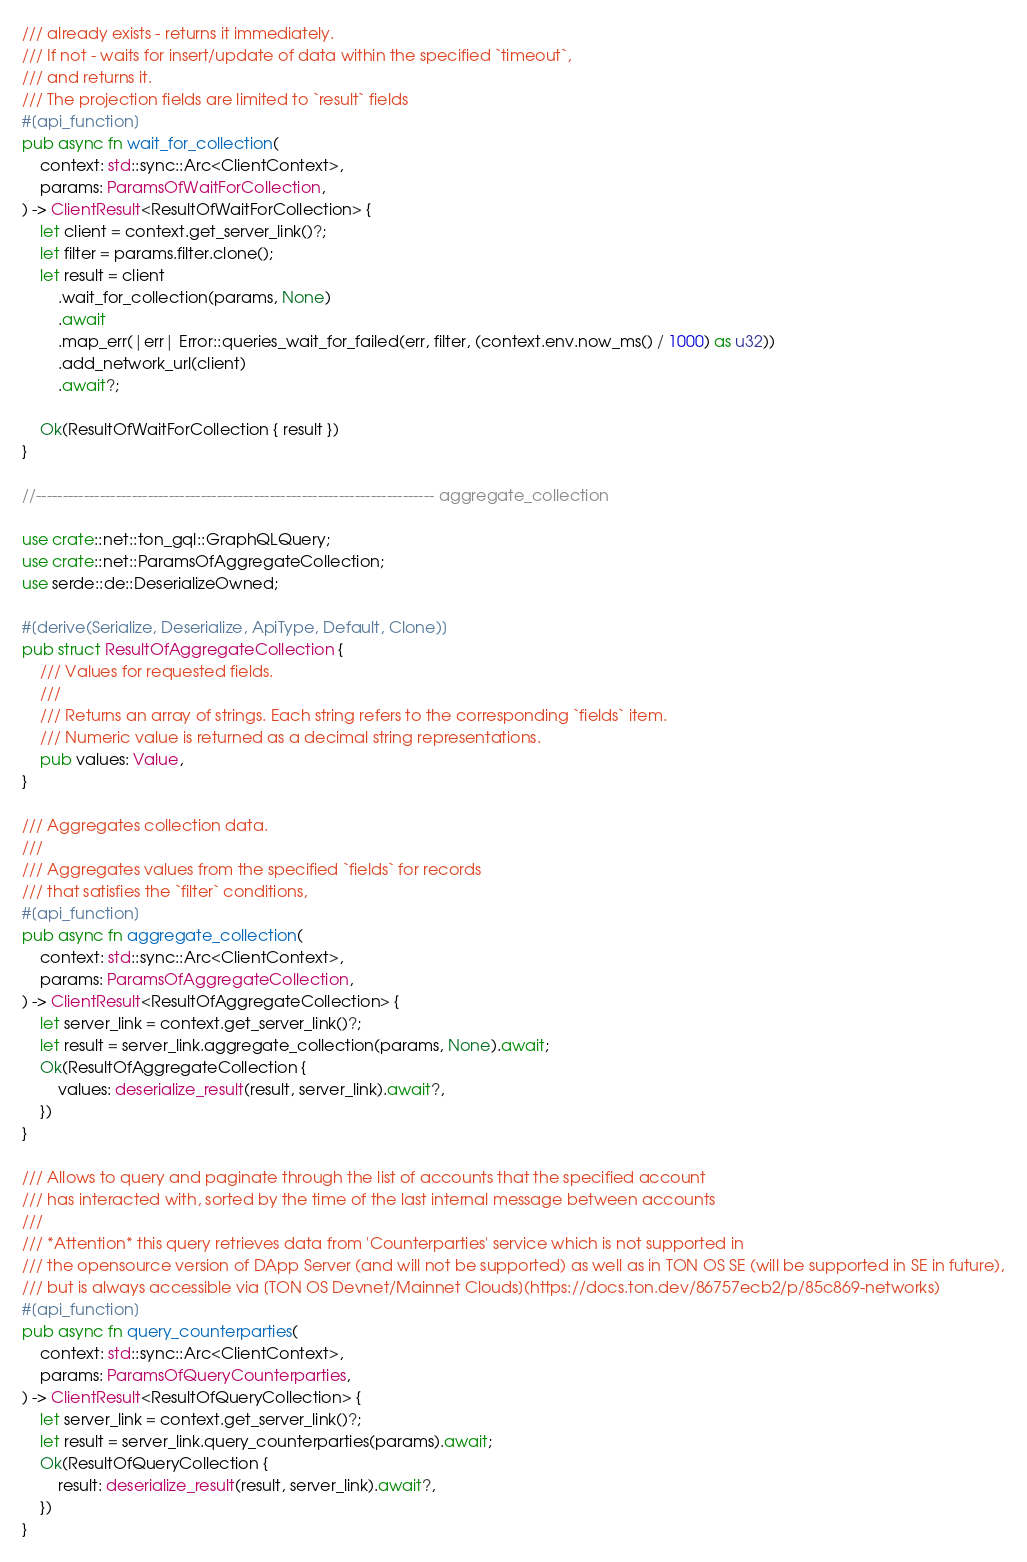Convert code to text. <code><loc_0><loc_0><loc_500><loc_500><_Rust_>/// already exists - returns it immediately.
/// If not - waits for insert/update of data within the specified `timeout`,
/// and returns it.
/// The projection fields are limited to `result` fields
#[api_function]
pub async fn wait_for_collection(
    context: std::sync::Arc<ClientContext>,
    params: ParamsOfWaitForCollection,
) -> ClientResult<ResultOfWaitForCollection> {
    let client = context.get_server_link()?;
    let filter = params.filter.clone();
    let result = client
        .wait_for_collection(params, None)
        .await
        .map_err(|err| Error::queries_wait_for_failed(err, filter, (context.env.now_ms() / 1000) as u32))
        .add_network_url(client)
        .await?;

    Ok(ResultOfWaitForCollection { result })
}

//--------------------------------------------------------------------------- aggregate_collection

use crate::net::ton_gql::GraphQLQuery;
use crate::net::ParamsOfAggregateCollection;
use serde::de::DeserializeOwned;

#[derive(Serialize, Deserialize, ApiType, Default, Clone)]
pub struct ResultOfAggregateCollection {
    /// Values for requested fields.
    ///
    /// Returns an array of strings. Each string refers to the corresponding `fields` item.
    /// Numeric value is returned as a decimal string representations.
    pub values: Value,
}

/// Aggregates collection data.
///
/// Aggregates values from the specified `fields` for records
/// that satisfies the `filter` conditions,
#[api_function]
pub async fn aggregate_collection(
    context: std::sync::Arc<ClientContext>,
    params: ParamsOfAggregateCollection,
) -> ClientResult<ResultOfAggregateCollection> {
    let server_link = context.get_server_link()?;
    let result = server_link.aggregate_collection(params, None).await;
    Ok(ResultOfAggregateCollection {
        values: deserialize_result(result, server_link).await?,
    })
}

/// Allows to query and paginate through the list of accounts that the specified account
/// has interacted with, sorted by the time of the last internal message between accounts
///
/// *Attention* this query retrieves data from 'Counterparties' service which is not supported in
/// the opensource version of DApp Server (and will not be supported) as well as in TON OS SE (will be supported in SE in future),
/// but is always accessible via [TON OS Devnet/Mainnet Clouds](https://docs.ton.dev/86757ecb2/p/85c869-networks)
#[api_function]
pub async fn query_counterparties(
    context: std::sync::Arc<ClientContext>,
    params: ParamsOfQueryCounterparties,
) -> ClientResult<ResultOfQueryCollection> {
    let server_link = context.get_server_link()?;
    let result = server_link.query_counterparties(params).await;
    Ok(ResultOfQueryCollection {
        result: deserialize_result(result, server_link).await?,
    })
}
</code> 